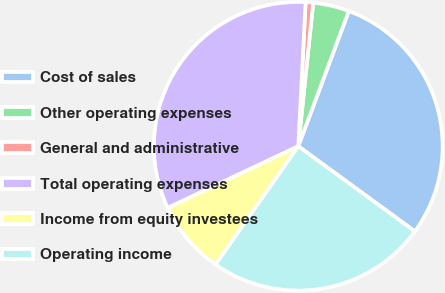Convert chart to OTSL. <chart><loc_0><loc_0><loc_500><loc_500><pie_chart><fcel>Cost of sales<fcel>Other operating expenses<fcel>General and administrative<fcel>Total operating expenses<fcel>Income from equity investees<fcel>Operating income<nl><fcel>29.35%<fcel>4.04%<fcel>0.84%<fcel>32.84%<fcel>8.27%<fcel>24.67%<nl></chart> 